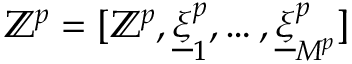<formula> <loc_0><loc_0><loc_500><loc_500>\mathbb { Z } ^ { p } = [ \mathbb { Z } ^ { p } , \underline { \xi } _ { 1 } ^ { p } , \dots , \underline { \xi } _ { M ^ { p } } ^ { p } ]</formula> 